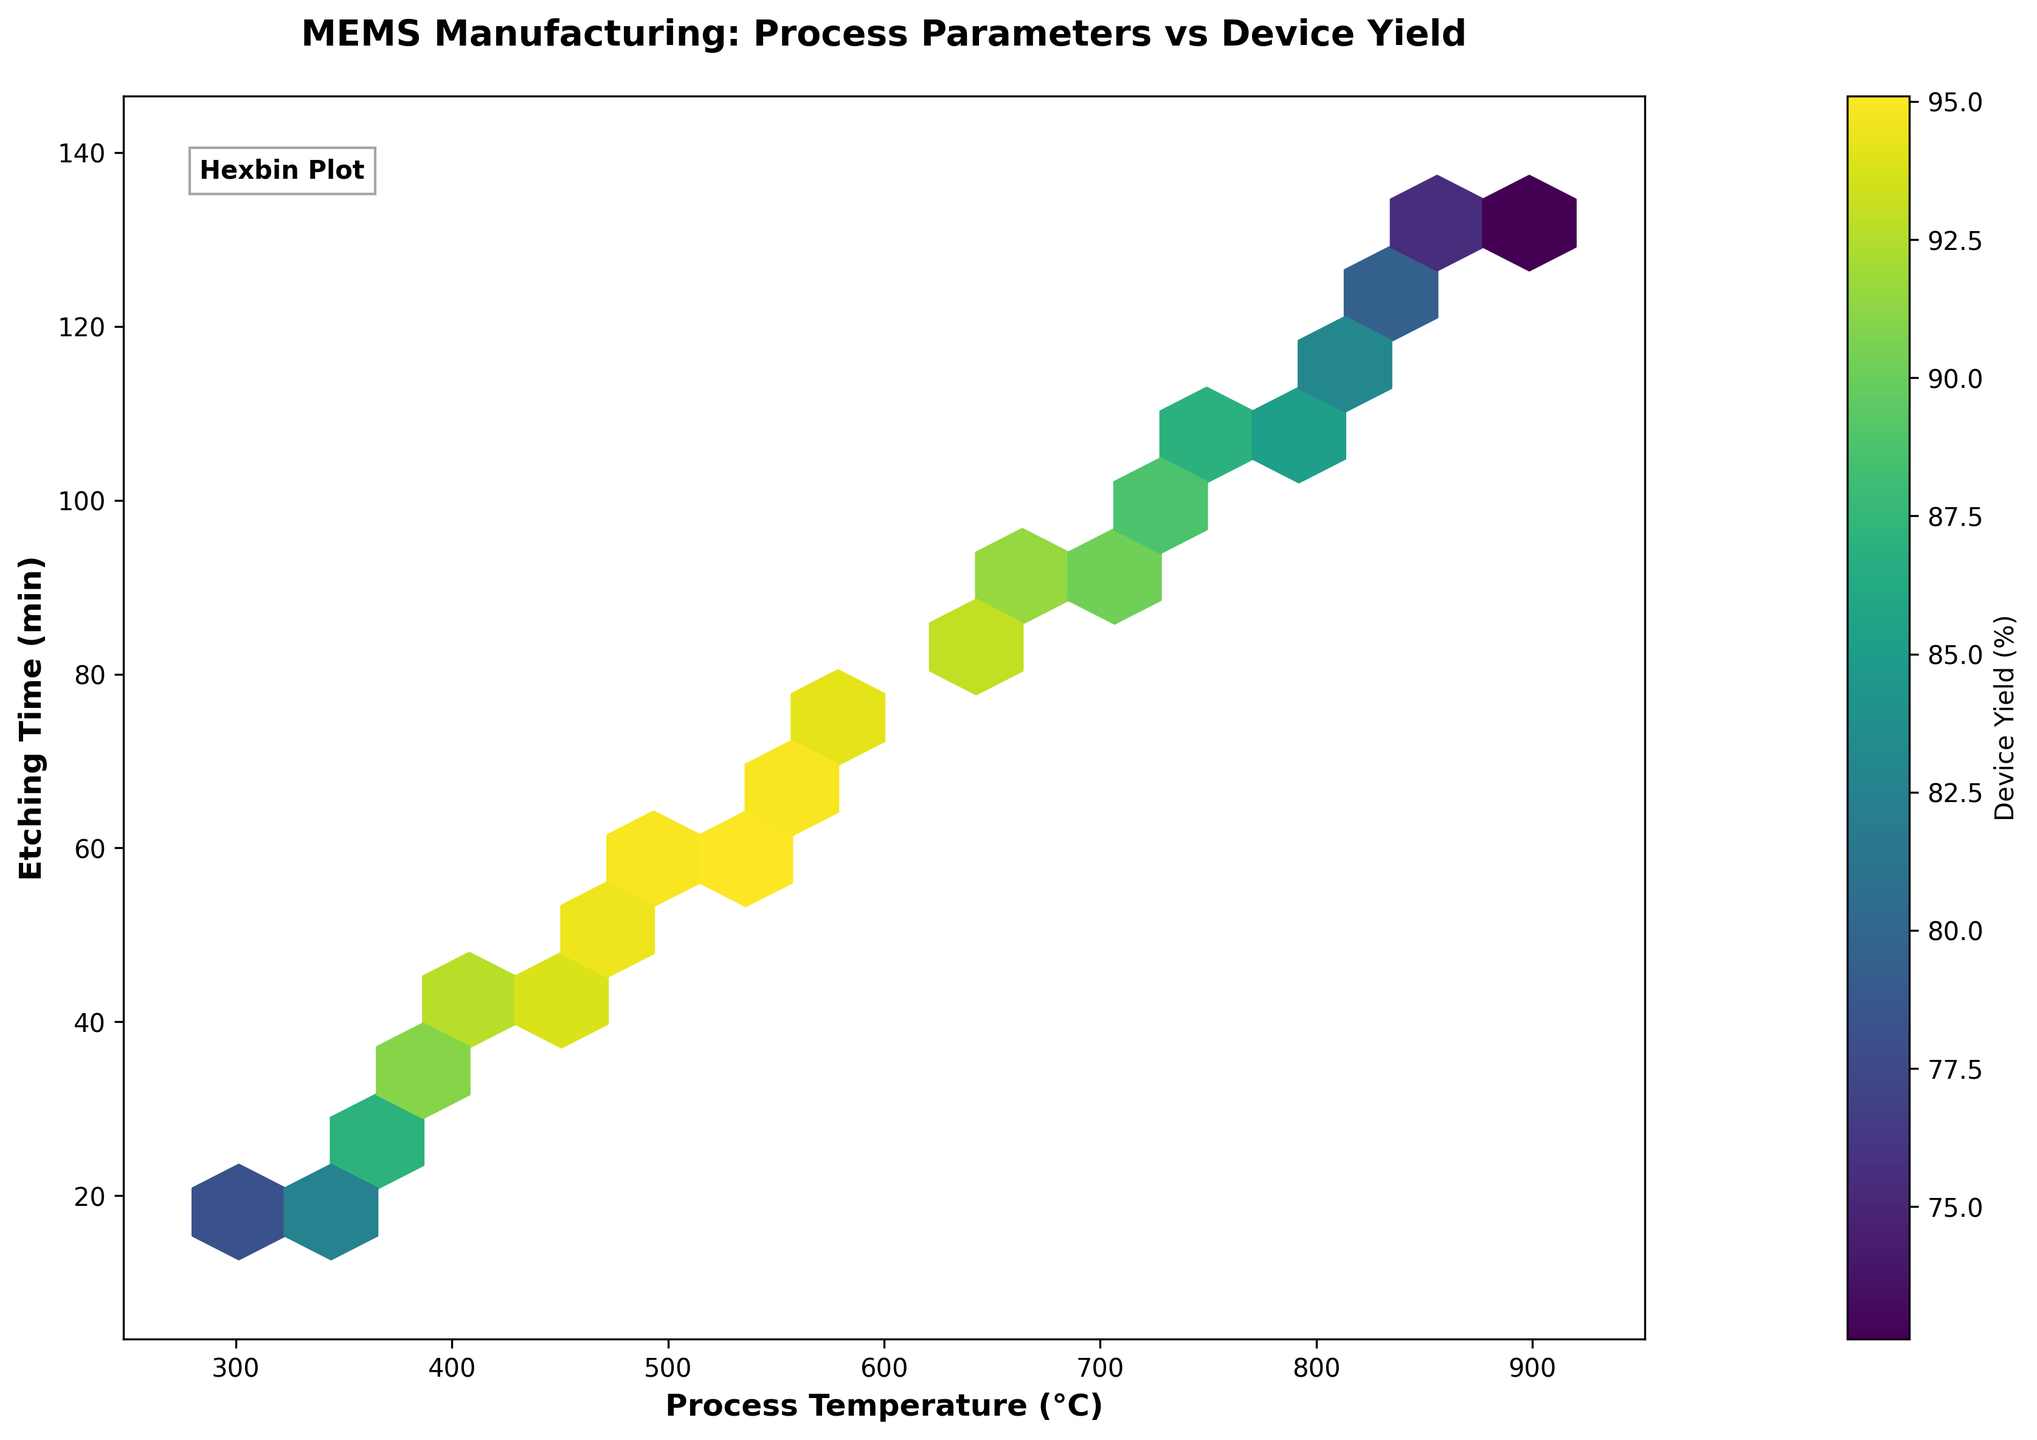What is the title of the hexbin plot? The title of the plot is displayed at the top center of the figure. It reads, "MEMS Manufacturing: Process Parameters vs Device Yield."
Answer: MEMS Manufacturing: Process Parameters vs Device Yield What does the color bar represent in the hexbin plot? The color bar is labeled "Device Yield (%)", indicating that the color intensity in the hexagonal bins represents the percentage of device yield.
Answer: Device Yield (%) What are the labels of the x-axis and y-axis? The labels for the x-axis and y-axis can be found directly below and to the left of the plot, respectively. The x-axis is labeled "Process Temperature (°C)" and the y-axis is labeled "Etching Time (min)."
Answer: Process Temperature (°C) and Etching Time (min) Which range of process temperatures shows the highest device yield? By observing the color intensity, the highest device yield corresponds to the darkest colors. The highest yield is in the temperature range of approximately 500 to 600°C.
Answer: 500 to 600°C What is the etching time range associated with the highest device yield? By looking at the darkest hexagons indicating the highest yield, the corresponding etching times fall in the range of approximately 55 to 75 minutes.
Answer: 55 to 75 minutes How does the device yield change as the process temperature increases from 300°C to 900°C? As the temperature increases, observe the color in the hexagons shifting from darker to lighter shades, indicating a decrease in device yield. This suggests that the device yield initially increases, peaks around 500-600°C, and then decreases.
Answer: Increases, peaks around 500-600°C, then decreases Comparing 375°C and 775°C, which process temperature has a higher device yield? By locating the colors corresponding to these temperatures, the hexagons around 375°C show darker colors compared to those around 775°C. This indicates a higher device yield at 375°C.
Answer: 375°C What trend can be observed in device yield with increasing etching time? The color transition from darker to lighter shades as the etching time increases from 15 to 135 minutes indicates that the device yield initially increases and then starts to decrease after reaching a peak.
Answer: Increases then decreases after a peak At what process temperature and etching time is the device yield at its minimum? By finding the lightest colored hexagon, which corresponds to the minimum device yield, it can be observed around 900°C and 135 minutes.
Answer: 900°C and 135 minutes What can you infer about the optimal conditions for maximum device yield in MEMS manufacturing? The optimal conditions for maximum device yield correspond to the darkest hexagons in the plot. This occurs around the temperature range of 500-600°C and etching time of 55-75 minutes.
Answer: 500-600°C and 55-75 minutes 